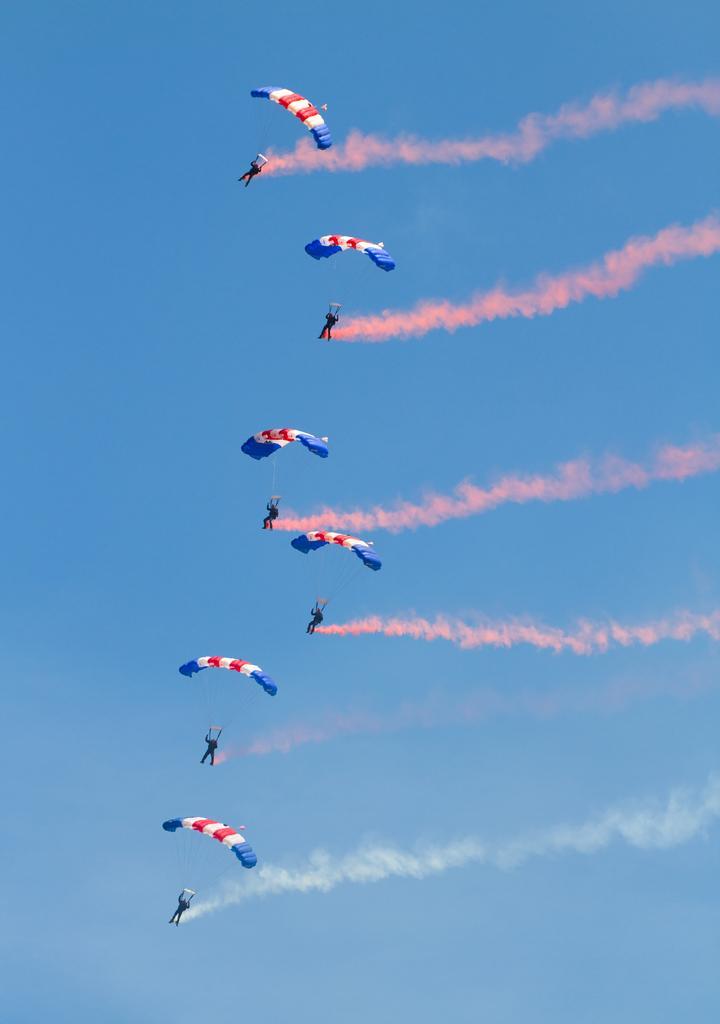Please provide a concise description of this image. In this image I can see few parachutes and persons hanging through parachute visible in the air and I can see the sky. 